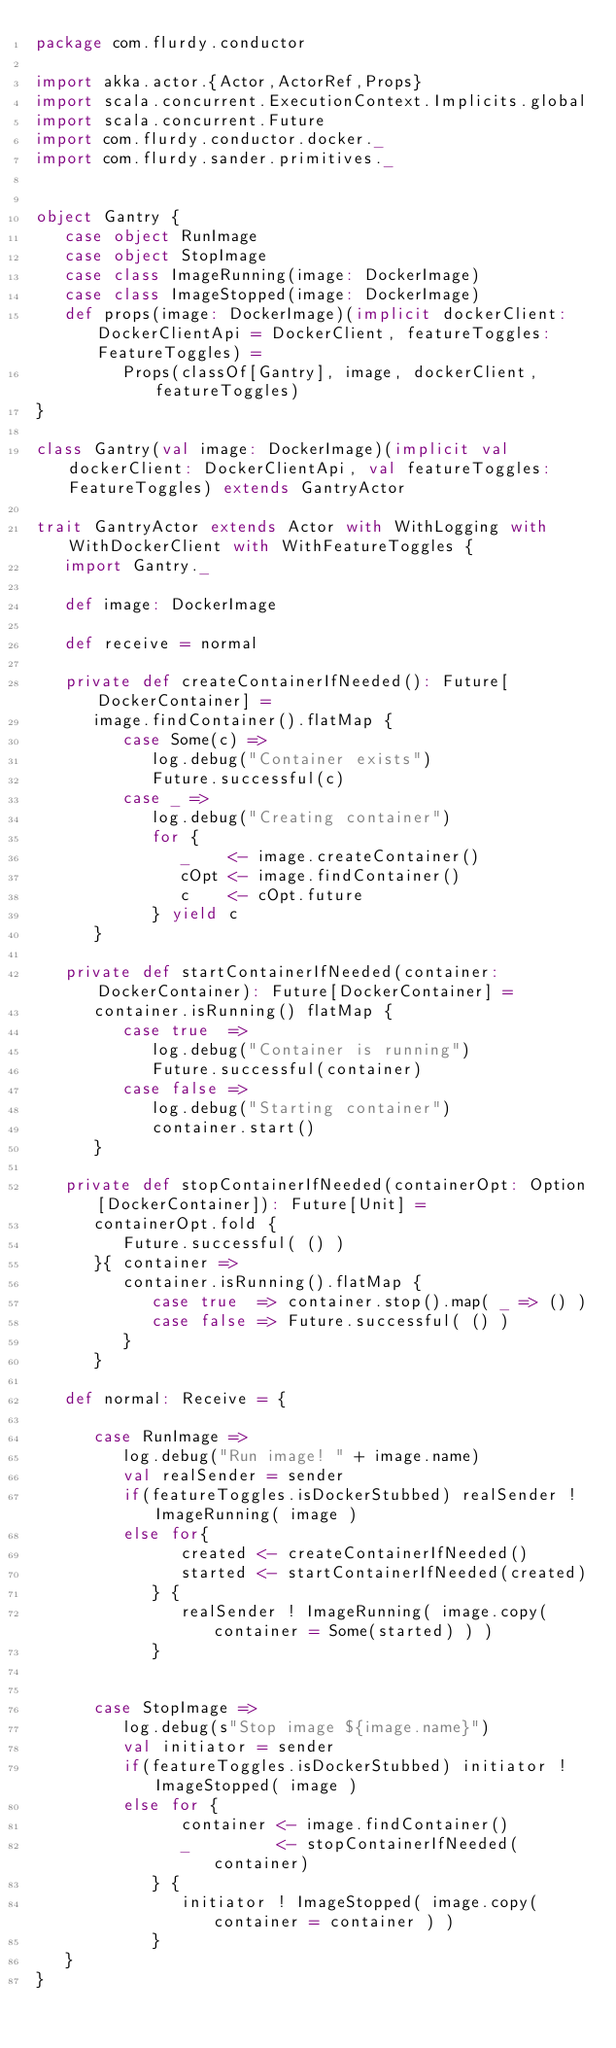Convert code to text. <code><loc_0><loc_0><loc_500><loc_500><_Scala_>package com.flurdy.conductor

import akka.actor.{Actor,ActorRef,Props}
import scala.concurrent.ExecutionContext.Implicits.global
import scala.concurrent.Future
import com.flurdy.conductor.docker._
import com.flurdy.sander.primitives._


object Gantry {
   case object RunImage
   case object StopImage
   case class ImageRunning(image: DockerImage)
   case class ImageStopped(image: DockerImage)
   def props(image: DockerImage)(implicit dockerClient: DockerClientApi = DockerClient, featureToggles: FeatureToggles) =
         Props(classOf[Gantry], image, dockerClient, featureToggles)
}

class Gantry(val image: DockerImage)(implicit val dockerClient: DockerClientApi, val featureToggles: FeatureToggles) extends GantryActor

trait GantryActor extends Actor with WithLogging with WithDockerClient with WithFeatureToggles {
   import Gantry._

   def image: DockerImage

   def receive = normal

   private def createContainerIfNeeded(): Future[DockerContainer] =
      image.findContainer().flatMap {
         case Some(c) =>
            log.debug("Container exists")
            Future.successful(c)
         case _ =>
            log.debug("Creating container")
            for {
               _    <- image.createContainer()
               cOpt <- image.findContainer()
               c    <- cOpt.future
            } yield c
      }

   private def startContainerIfNeeded(container: DockerContainer): Future[DockerContainer] =
      container.isRunning() flatMap {
         case true  =>
            log.debug("Container is running")
            Future.successful(container)
         case false =>
            log.debug("Starting container")
            container.start()
      }

   private def stopContainerIfNeeded(containerOpt: Option[DockerContainer]): Future[Unit] =
      containerOpt.fold {
         Future.successful( () )
      }{ container =>
         container.isRunning().flatMap {
            case true  => container.stop().map( _ => () )
            case false => Future.successful( () )
         }
      }

   def normal: Receive = {

      case RunImage =>
         log.debug("Run image! " + image.name)
         val realSender = sender
         if(featureToggles.isDockerStubbed) realSender ! ImageRunning( image )
         else for{
               created <- createContainerIfNeeded()
               started <- startContainerIfNeeded(created)
            } {
               realSender ! ImageRunning( image.copy( container = Some(started) ) )
            }
         

      case StopImage =>
         log.debug(s"Stop image ${image.name}")
         val initiator = sender
         if(featureToggles.isDockerStubbed) initiator ! ImageStopped( image )
         else for {
               container <- image.findContainer()
               _         <- stopContainerIfNeeded(container)
            } {
               initiator ! ImageStopped( image.copy( container = container ) )
            }
   }
}
</code> 